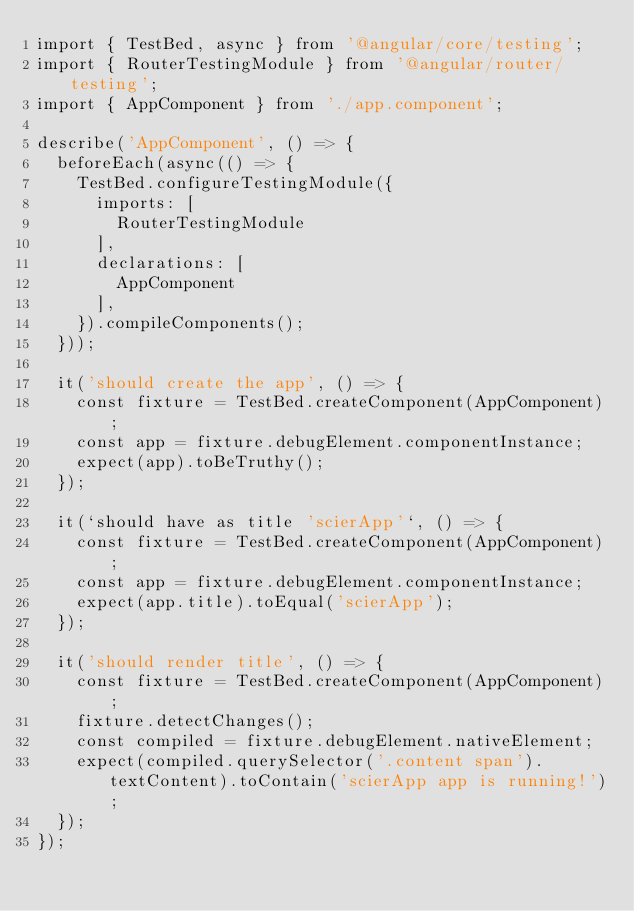<code> <loc_0><loc_0><loc_500><loc_500><_TypeScript_>import { TestBed, async } from '@angular/core/testing';
import { RouterTestingModule } from '@angular/router/testing';
import { AppComponent } from './app.component';

describe('AppComponent', () => {
  beforeEach(async(() => {
    TestBed.configureTestingModule({
      imports: [
        RouterTestingModule
      ],
      declarations: [
        AppComponent
      ],
    }).compileComponents();
  }));

  it('should create the app', () => {
    const fixture = TestBed.createComponent(AppComponent);
    const app = fixture.debugElement.componentInstance;
    expect(app).toBeTruthy();
  });

  it(`should have as title 'scierApp'`, () => {
    const fixture = TestBed.createComponent(AppComponent);
    const app = fixture.debugElement.componentInstance;
    expect(app.title).toEqual('scierApp');
  });

  it('should render title', () => {
    const fixture = TestBed.createComponent(AppComponent);
    fixture.detectChanges();
    const compiled = fixture.debugElement.nativeElement;
    expect(compiled.querySelector('.content span').textContent).toContain('scierApp app is running!');
  });
});
</code> 